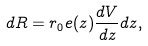<formula> <loc_0><loc_0><loc_500><loc_500>d R = r _ { 0 } e ( z ) \frac { d V } { d z } d z ,</formula> 